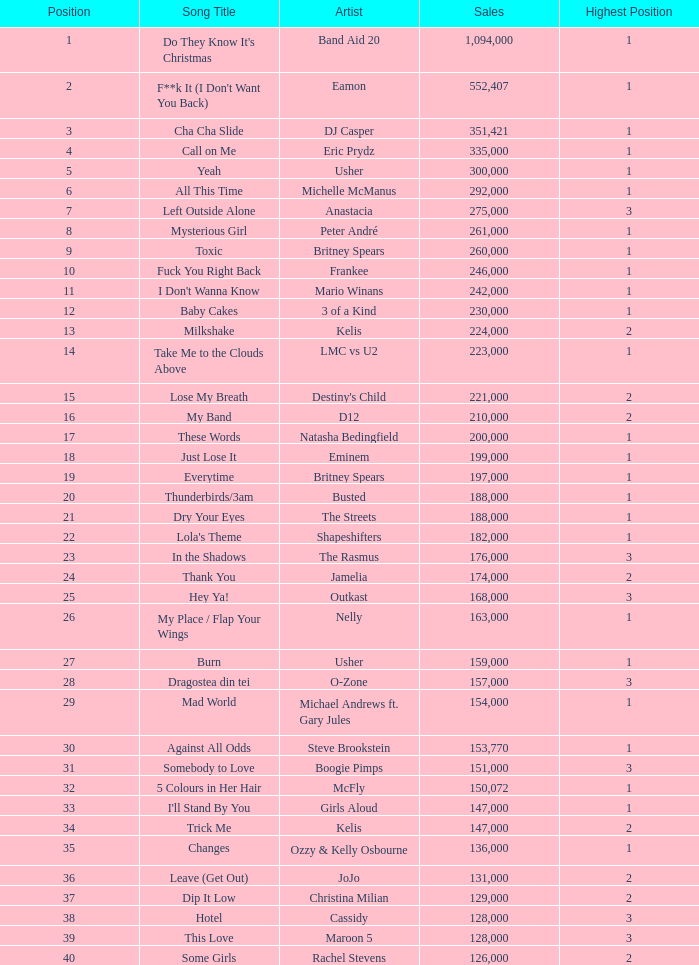For songs ranked higher than 3rd place, what is the greatest sales figure achieved? None. 